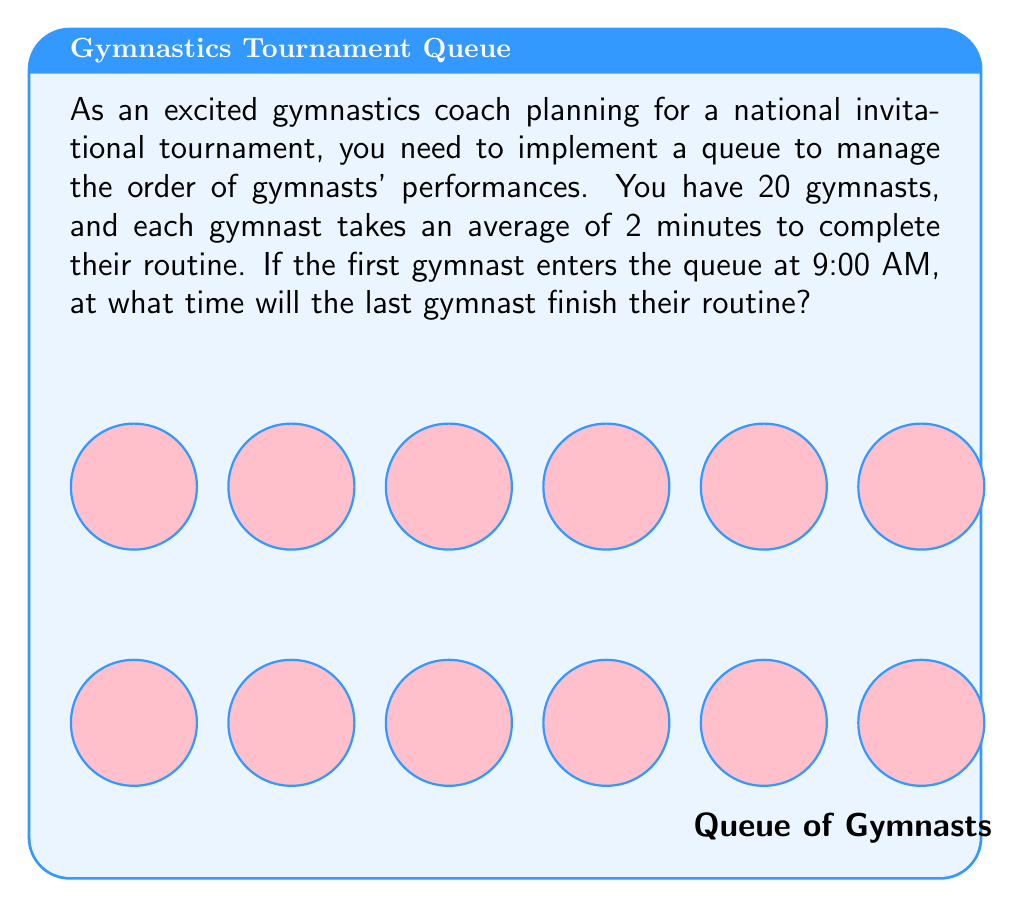Show me your answer to this math problem. Let's break this down step-by-step:

1) First, we need to calculate the total time it will take for all gymnasts to perform:
   $$ \text{Total time} = \text{Number of gymnasts} \times \text{Time per gymnast} $$
   $$ \text{Total time} = 20 \times 2 \text{ minutes} = 40 \text{ minutes} $$

2) Now, we know the first gymnast enters the queue at 9:00 AM. The last gymnast will finish 40 minutes after the start time.

3) To add 40 minutes to 9:00 AM:
   - 40 minutes is less than an hour, so the hour will remain 9
   - 40 minutes = 9:40 AM

Therefore, the last gymnast will finish their routine at 9:40 AM.
Answer: 9:40 AM 